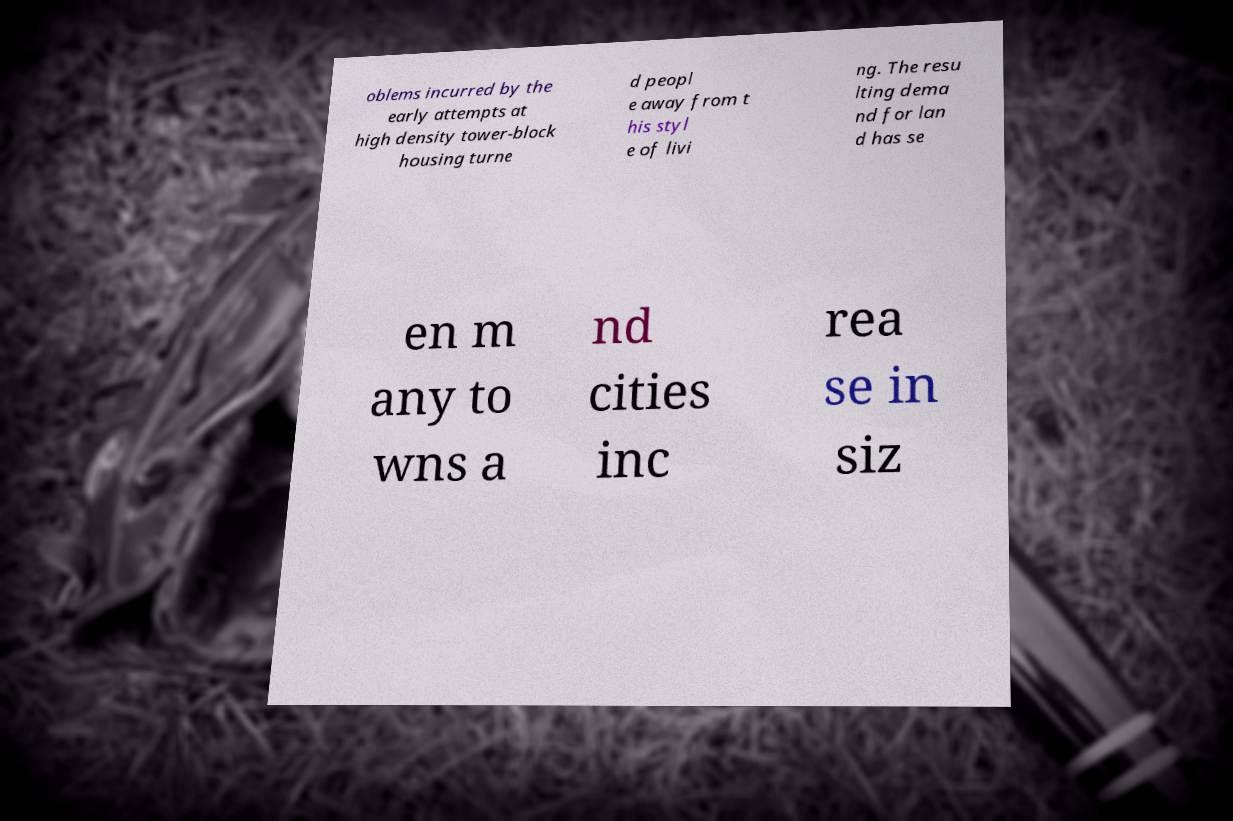What messages or text are displayed in this image? I need them in a readable, typed format. oblems incurred by the early attempts at high density tower-block housing turne d peopl e away from t his styl e of livi ng. The resu lting dema nd for lan d has se en m any to wns a nd cities inc rea se in siz 